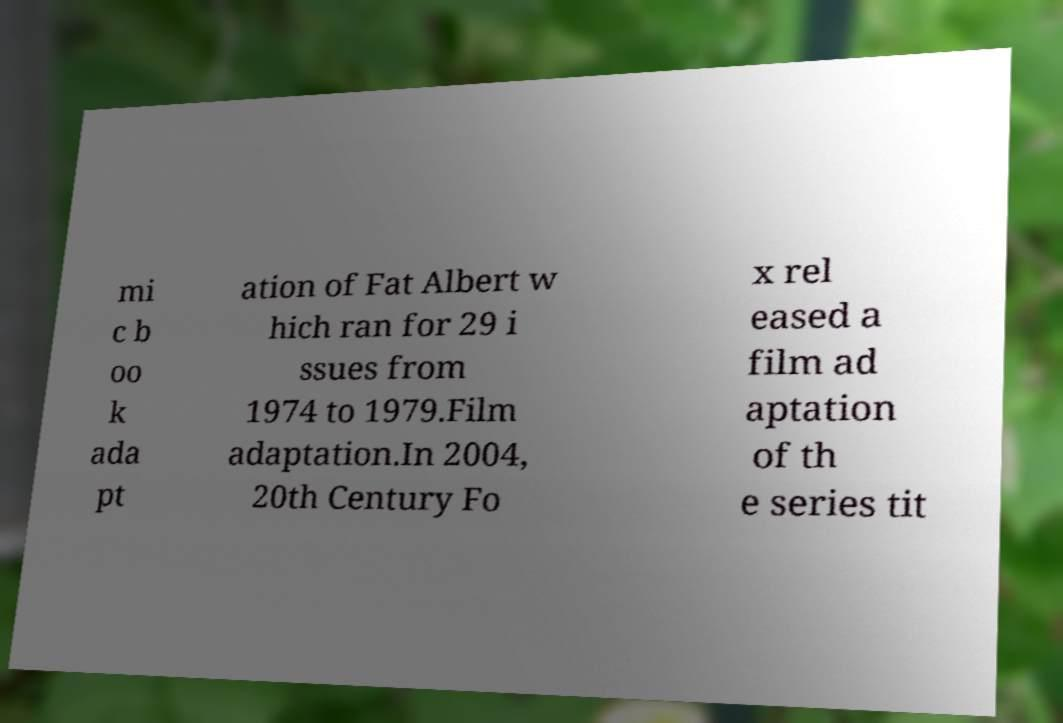There's text embedded in this image that I need extracted. Can you transcribe it verbatim? mi c b oo k ada pt ation of Fat Albert w hich ran for 29 i ssues from 1974 to 1979.Film adaptation.In 2004, 20th Century Fo x rel eased a film ad aptation of th e series tit 